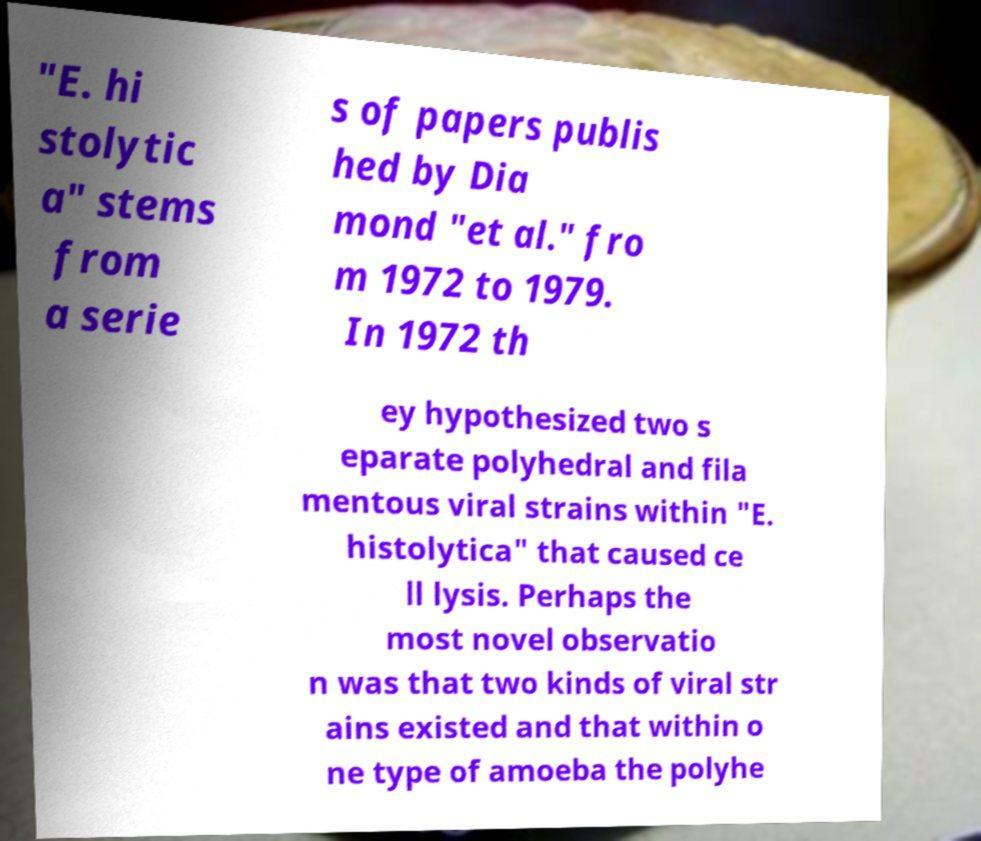Could you extract and type out the text from this image? "E. hi stolytic a" stems from a serie s of papers publis hed by Dia mond "et al." fro m 1972 to 1979. In 1972 th ey hypothesized two s eparate polyhedral and fila mentous viral strains within "E. histolytica" that caused ce ll lysis. Perhaps the most novel observatio n was that two kinds of viral str ains existed and that within o ne type of amoeba the polyhe 